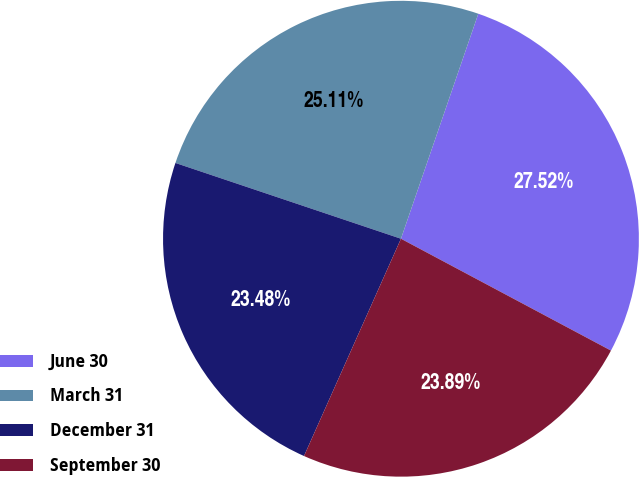Convert chart. <chart><loc_0><loc_0><loc_500><loc_500><pie_chart><fcel>June 30<fcel>March 31<fcel>December 31<fcel>September 30<nl><fcel>27.52%<fcel>25.11%<fcel>23.48%<fcel>23.89%<nl></chart> 